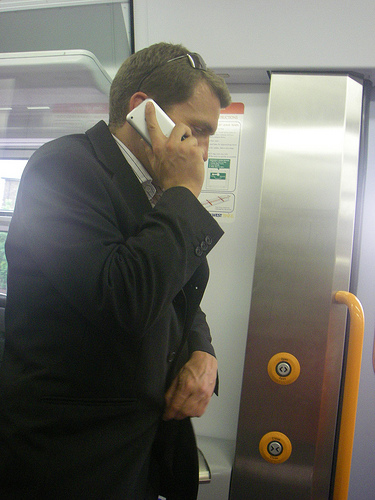What is the man wearing? The man is wearing a formal black jacket. 